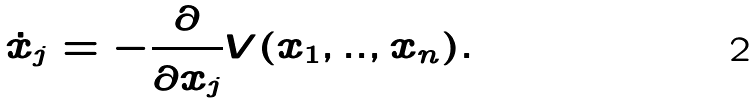<formula> <loc_0><loc_0><loc_500><loc_500>\dot { x } _ { j } = - \frac { \partial } { \partial x _ { j } } V ( x _ { 1 } , . . , x _ { n } ) .</formula> 